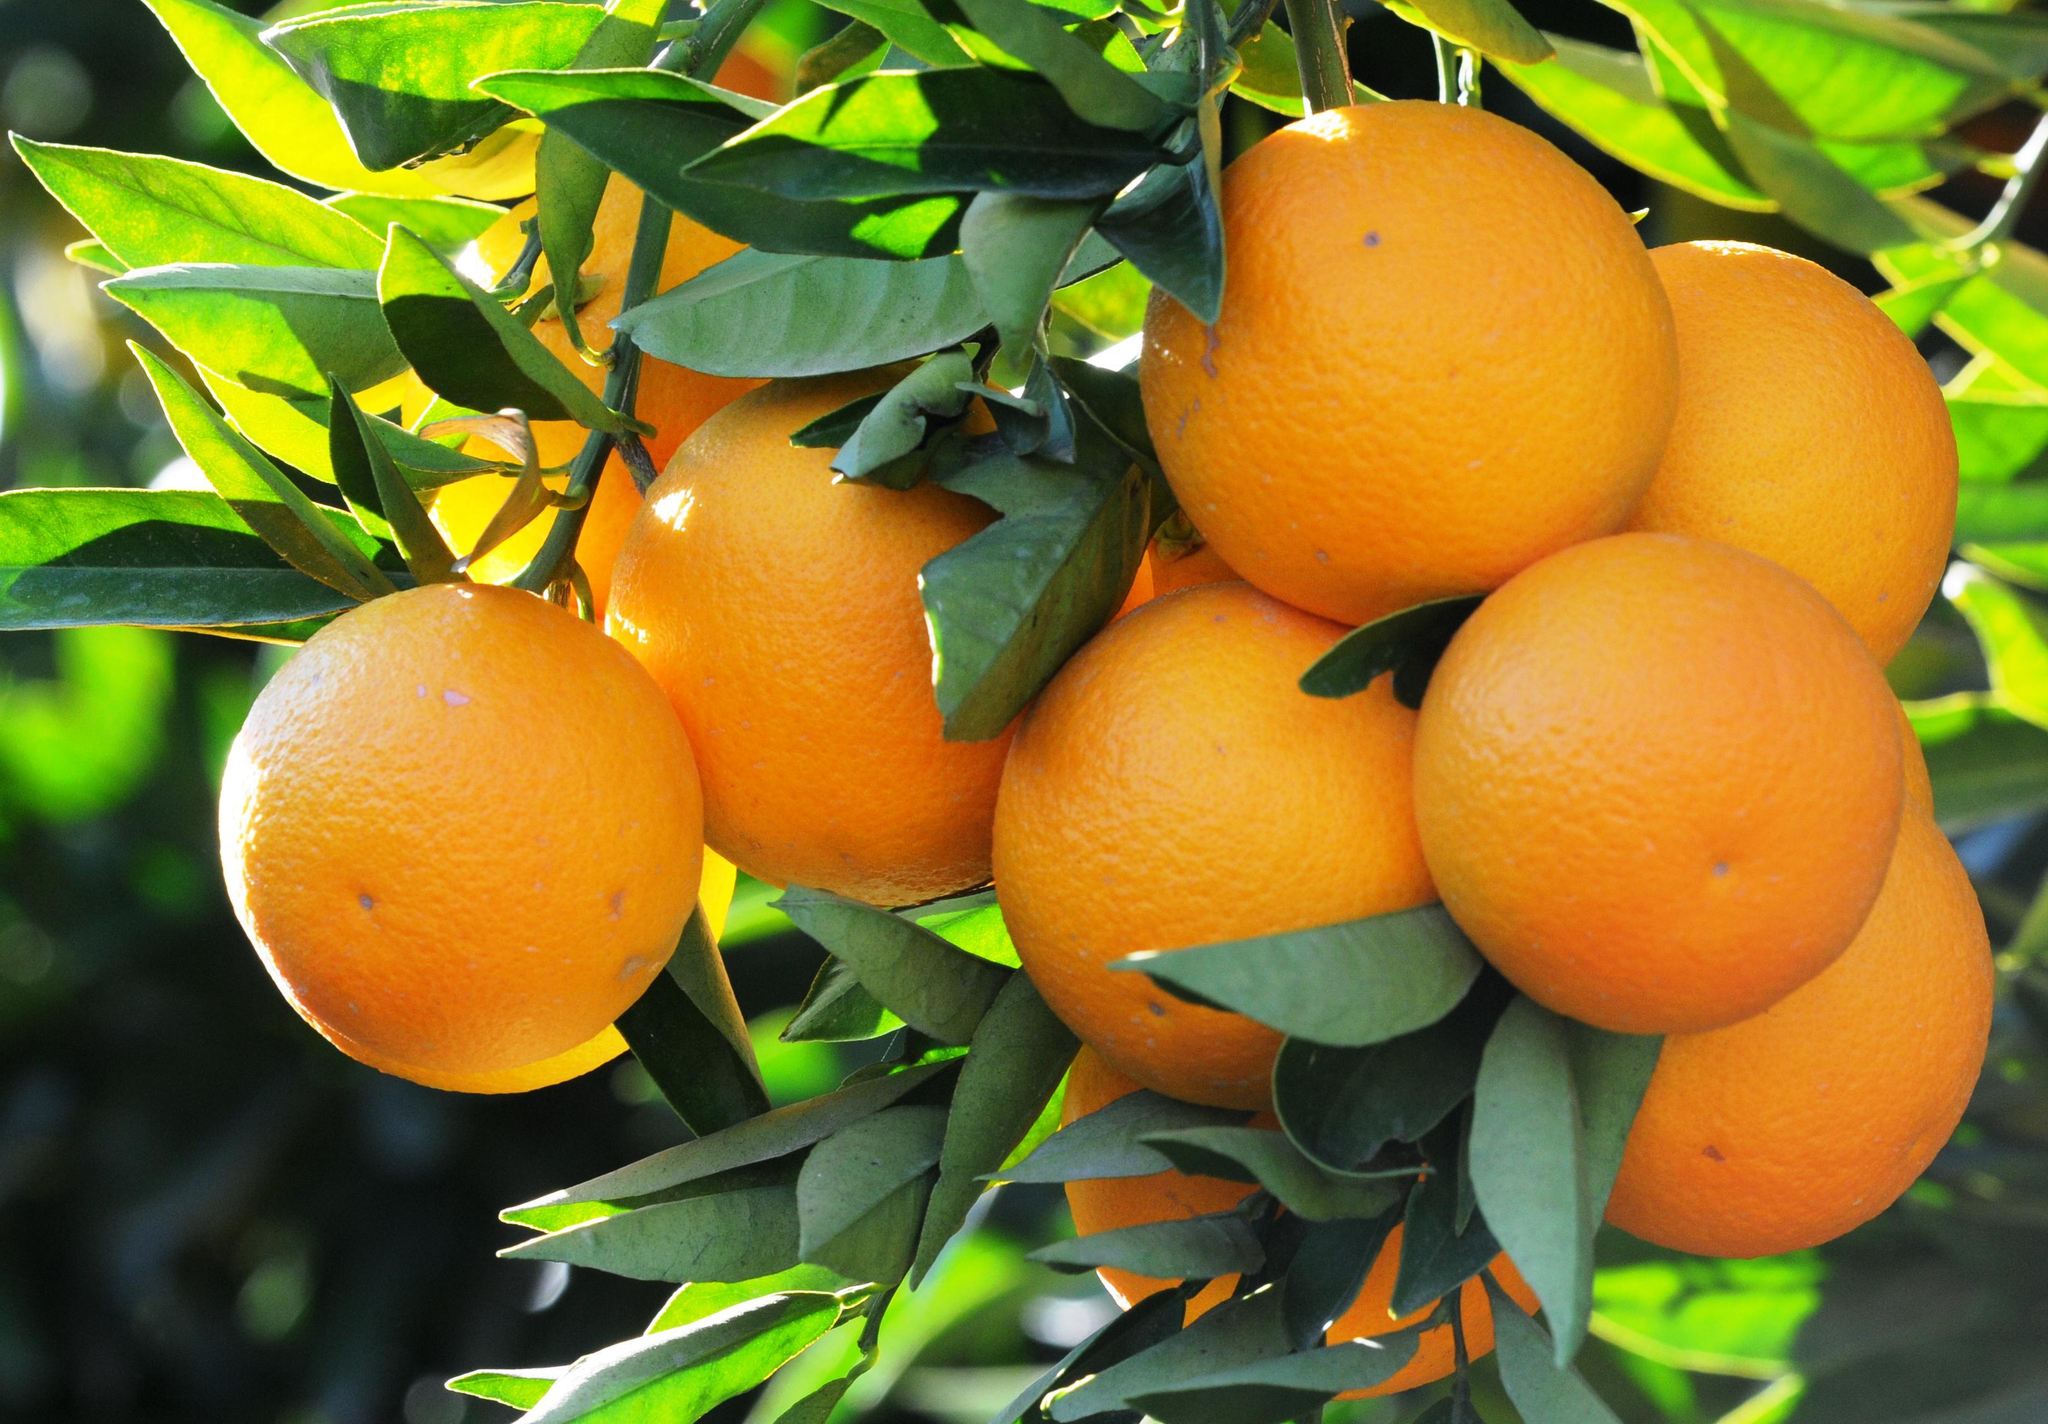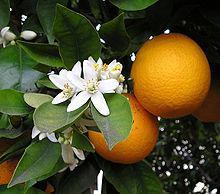The first image is the image on the left, the second image is the image on the right. Assess this claim about the two images: "None of the orange trees have bloomed.". Correct or not? Answer yes or no. No. The first image is the image on the left, the second image is the image on the right. Examine the images to the left and right. Is the description "An orange tree is flowering." accurate? Answer yes or no. Yes. 